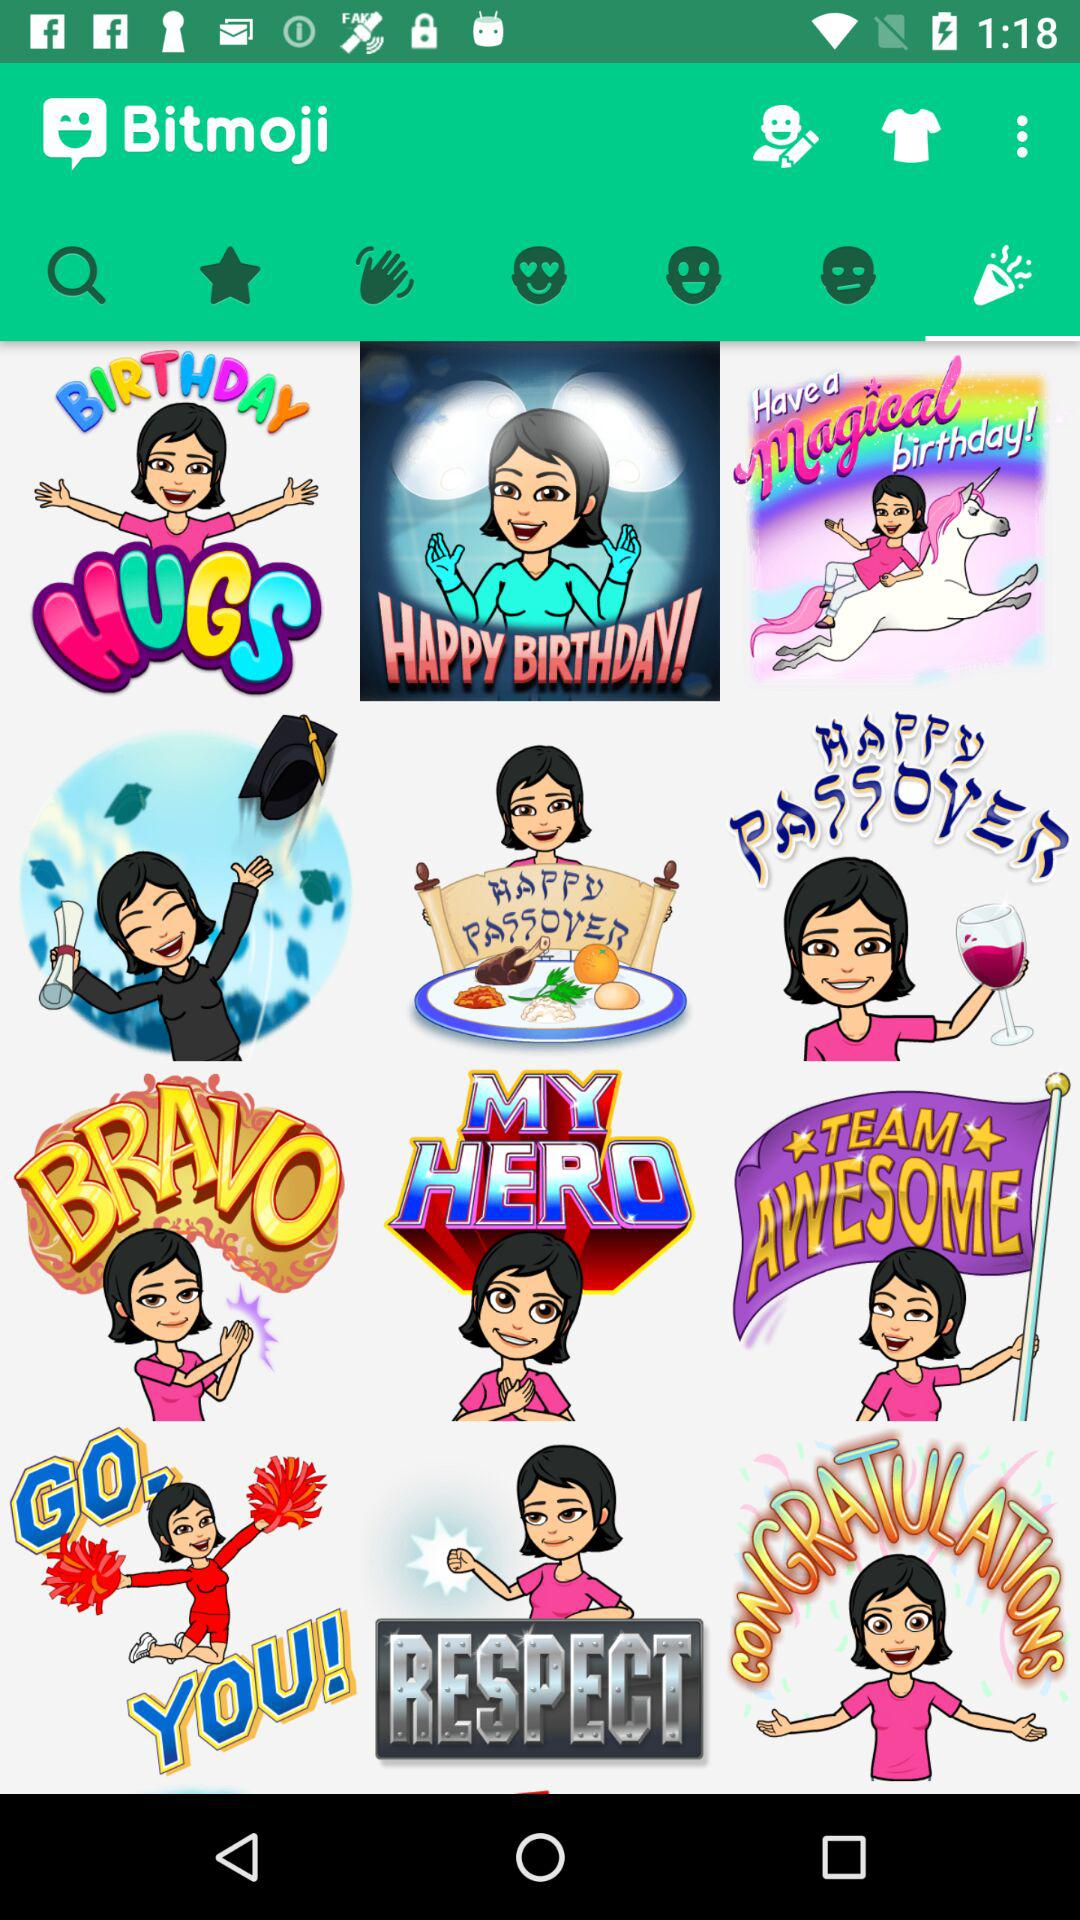What is the name of the application? The name of the application is "Bitmoji". 